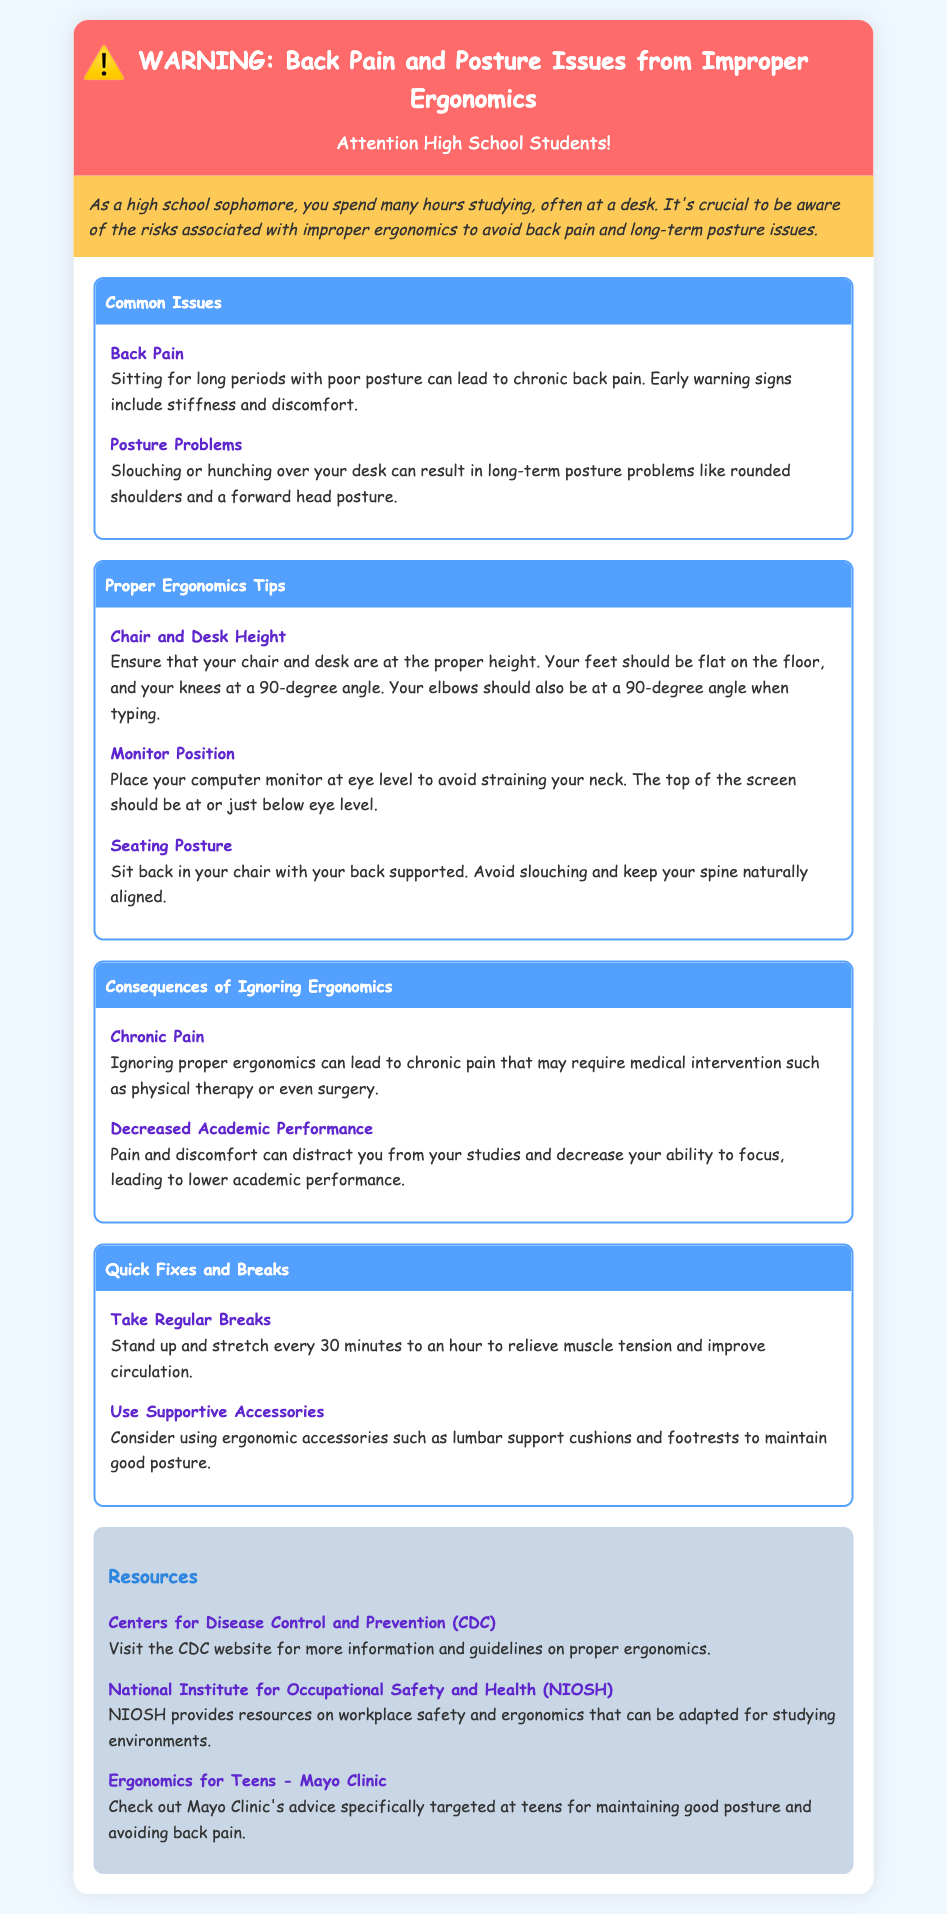What is the main warning of the document? The document warns about the risks associated with improper ergonomics, specifically back pain and posture issues.
Answer: Back Pain and Posture Issues What is one common issue mentioned related to posture? The document lists "Slouching or hunching over your desk" as a common issue that can lead to long-term problems.
Answer: Posture Problems What should your elbows be at when typing according to proper ergonomics? The document states that when typing, your elbows should be at a 90-degree angle.
Answer: 90-degree angle What is a consequence of ignoring proper ergonomics? The document mentions that ignoring proper ergonomics can lead to chronic pain which may require medical intervention.
Answer: Chronic Pain How often should you stand up and stretch? The document advises to stand up and stretch every 30 minutes to an hour.
Answer: Every 30 minutes to an hour What resource does the document suggest for ergonomics information? The document suggests visiting the CDC website for more information and guidelines on proper ergonomics.
Answer: Centers for Disease Control and Prevention (CDC) What should the top of the computer monitor be at? The document states that the top of the computer monitor should be at or just below eye level.
Answer: At or just below eye level What type of accessories can improve your posture? The document recommends using ergonomic accessories such as lumbar support cushions and footrests.
Answer: Lumbar support cushions and footrests 